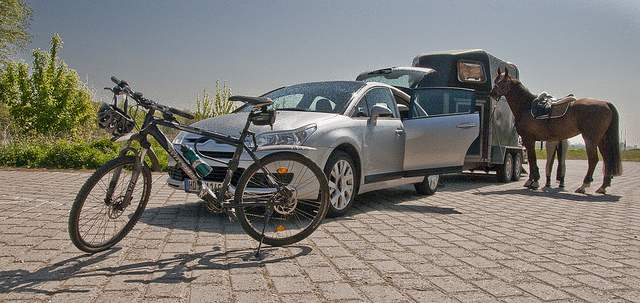<image>What animal is pulling the carriage? It is ambiguous which animal is pulling the carriage. It can be a horse or none. What is the gold and black structure? I am not sure what the gold and black structure is. It could be a bicycle, bike, trailer or it might not be in the image. What animal is pulling the carriage? I am not sure what animal is pulling the carriage. It can be seen both horse and none. What is the gold and black structure? I am not sure what the gold and black structure is. It can be seen as 'bicycle', 'bike', or 'trailer'. 